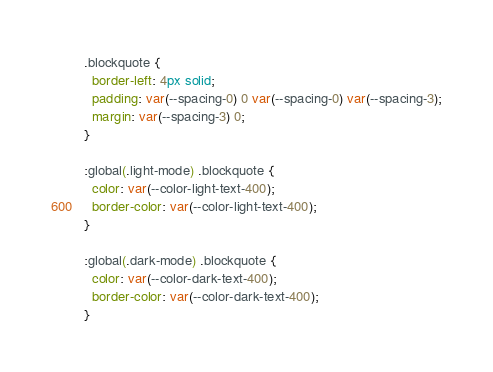Convert code to text. <code><loc_0><loc_0><loc_500><loc_500><_CSS_>.blockquote {
  border-left: 4px solid;
  padding: var(--spacing-0) 0 var(--spacing-0) var(--spacing-3);
  margin: var(--spacing-3) 0;
}

:global(.light-mode) .blockquote {
  color: var(--color-light-text-400);
  border-color: var(--color-light-text-400);
}

:global(.dark-mode) .blockquote {
  color: var(--color-dark-text-400);
  border-color: var(--color-dark-text-400);
}
</code> 